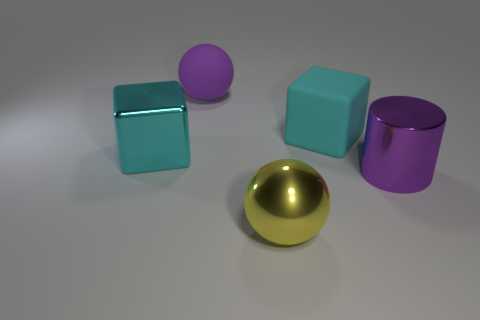There is a cyan block that is the same size as the cyan matte object; what material is it?
Your answer should be very brief. Metal. Are there any yellow spheres of the same size as the purple rubber thing?
Give a very brief answer. Yes. Does the shiny thing that is behind the shiny cylinder have the same color as the big rubber block that is on the right side of the large yellow metal thing?
Keep it short and to the point. Yes. What number of shiny objects are either cyan blocks or large objects?
Keep it short and to the point. 3. There is a cyan object that is right of the large ball in front of the large metal cylinder; what number of big cyan matte objects are in front of it?
Keep it short and to the point. 0. There is a ball that is the same material as the large cylinder; what size is it?
Keep it short and to the point. Large. What number of other cubes have the same color as the large matte block?
Your answer should be compact. 1. There is a block that is on the left side of the yellow thing; is its size the same as the purple ball?
Your response must be concise. Yes. There is a object that is to the left of the large purple cylinder and in front of the cyan metallic cube; what is its color?
Make the answer very short. Yellow. What number of things are either big rubber objects or large things right of the big metallic cube?
Make the answer very short. 4. 